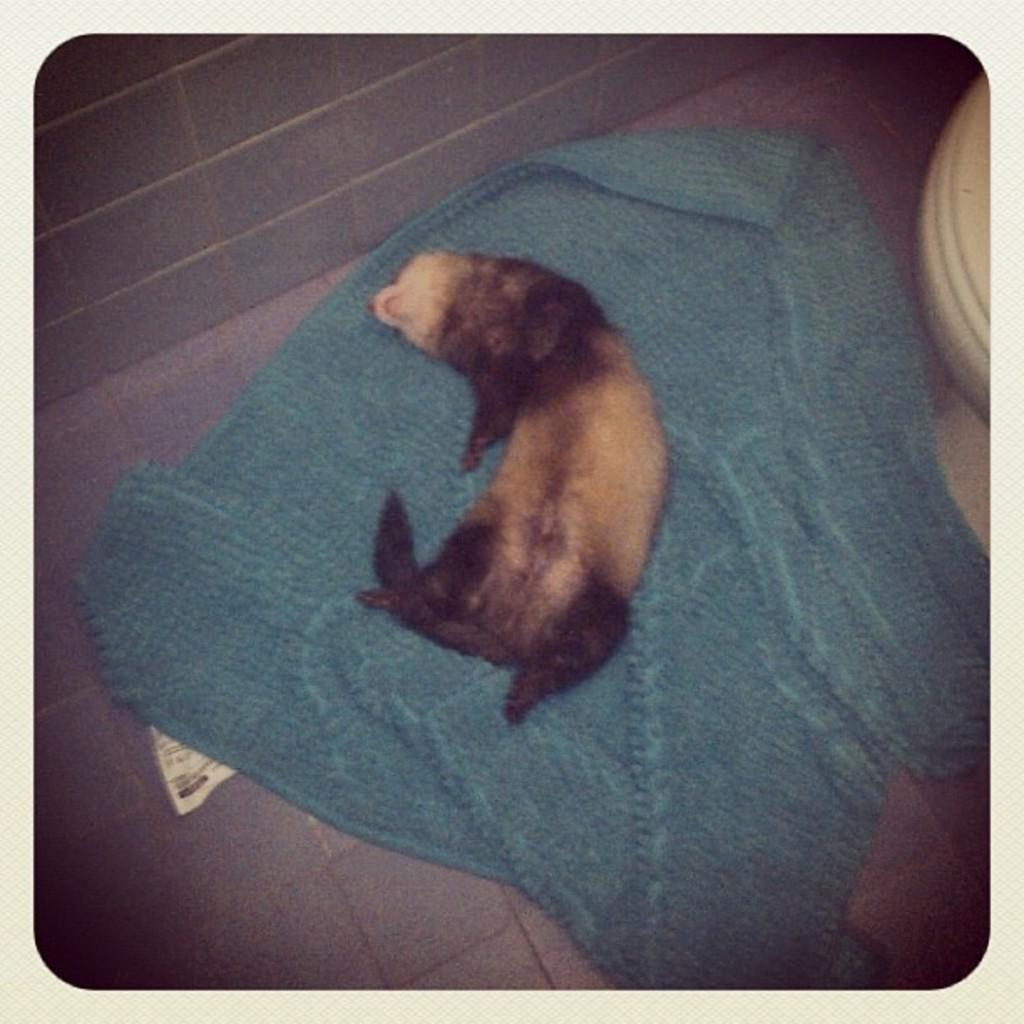What type of animal is in the image? There is an animal in the image, but the specific type cannot be determined from the provided facts. What is the animal doing in the image? The animal is lying on a blanket. What can be seen in the background of the image? Walls and a toilet seat are visible in the background of the image. What type of horn can be seen on the animal in the image? There is no horn visible on the animal in the image. How many forks are present in the image? There is no fork present in the image. 